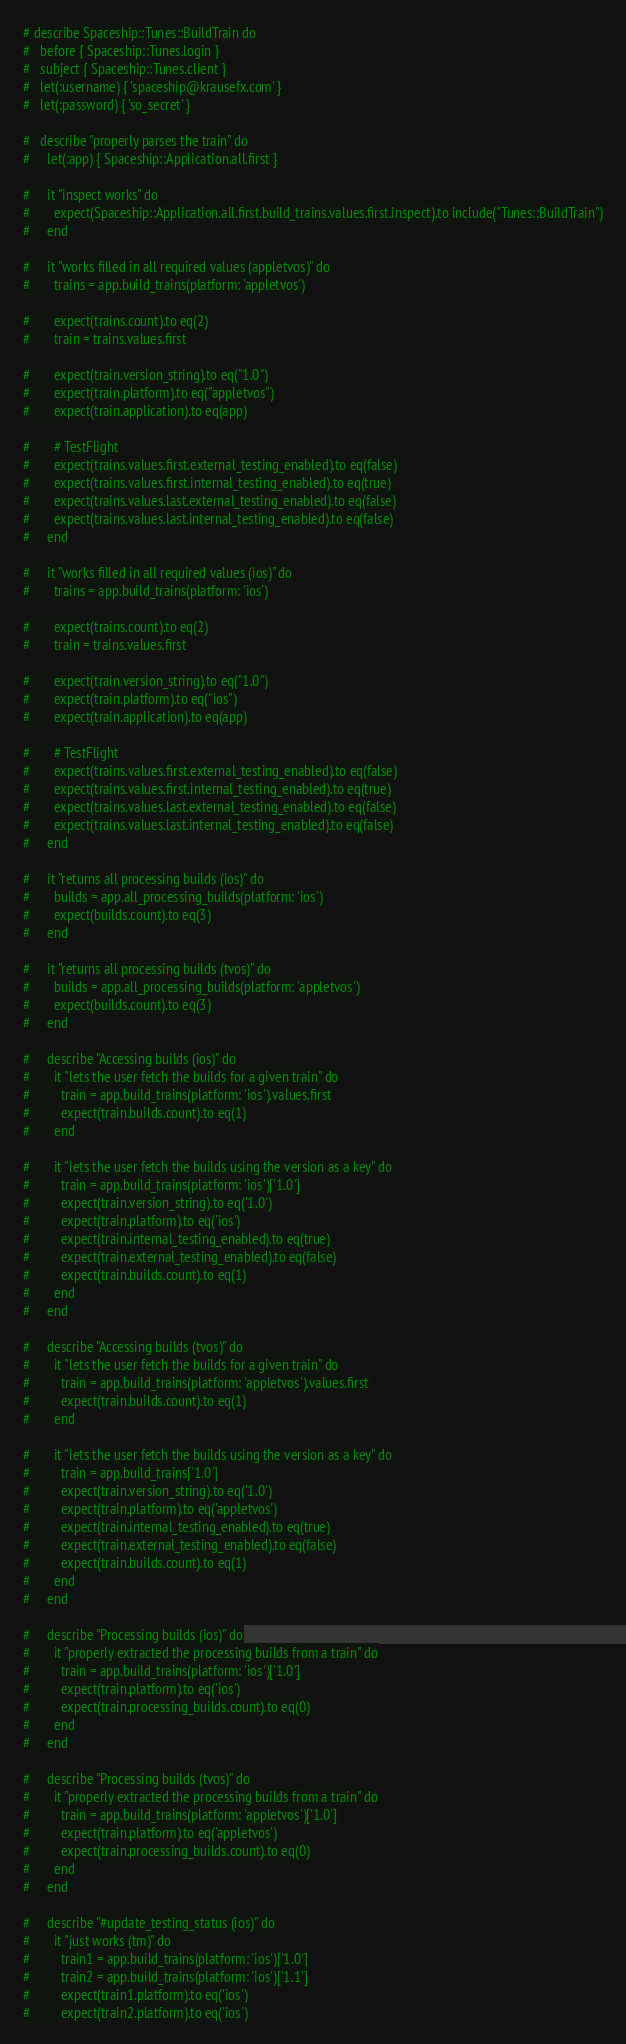<code> <loc_0><loc_0><loc_500><loc_500><_Ruby_># describe Spaceship::Tunes::BuildTrain do
#   before { Spaceship::Tunes.login }
#   subject { Spaceship::Tunes.client }
#   let(:username) { 'spaceship@krausefx.com' }
#   let(:password) { 'so_secret' }

#   describe "properly parses the train" do
#     let(:app) { Spaceship::Application.all.first }

#     it "inspect works" do
#       expect(Spaceship::Application.all.first.build_trains.values.first.inspect).to include("Tunes::BuildTrain")
#     end

#     it "works filled in all required values (appletvos)" do
#       trains = app.build_trains(platform: 'appletvos')

#       expect(trains.count).to eq(2)
#       train = trains.values.first

#       expect(train.version_string).to eq("1.0")
#       expect(train.platform).to eq("appletvos")
#       expect(train.application).to eq(app)

#       # TestFlight
#       expect(trains.values.first.external_testing_enabled).to eq(false)
#       expect(trains.values.first.internal_testing_enabled).to eq(true)
#       expect(trains.values.last.external_testing_enabled).to eq(false)
#       expect(trains.values.last.internal_testing_enabled).to eq(false)
#     end

#     it "works filled in all required values (ios)" do
#       trains = app.build_trains(platform: 'ios')

#       expect(trains.count).to eq(2)
#       train = trains.values.first

#       expect(train.version_string).to eq("1.0")
#       expect(train.platform).to eq("ios")
#       expect(train.application).to eq(app)

#       # TestFlight
#       expect(trains.values.first.external_testing_enabled).to eq(false)
#       expect(trains.values.first.internal_testing_enabled).to eq(true)
#       expect(trains.values.last.external_testing_enabled).to eq(false)
#       expect(trains.values.last.internal_testing_enabled).to eq(false)
#     end

#     it "returns all processing builds (ios)" do
#       builds = app.all_processing_builds(platform: 'ios')
#       expect(builds.count).to eq(3)
#     end

#     it "returns all processing builds (tvos)" do
#       builds = app.all_processing_builds(platform: 'appletvos')
#       expect(builds.count).to eq(3)
#     end

#     describe "Accessing builds (ios)" do
#       it "lets the user fetch the builds for a given train" do
#         train = app.build_trains(platform: 'ios').values.first
#         expect(train.builds.count).to eq(1)
#       end

#       it "lets the user fetch the builds using the version as a key" do
#         train = app.build_trains(platform: 'ios')['1.0']
#         expect(train.version_string).to eq('1.0')
#         expect(train.platform).to eq('ios')
#         expect(train.internal_testing_enabled).to eq(true)
#         expect(train.external_testing_enabled).to eq(false)
#         expect(train.builds.count).to eq(1)
#       end
#     end

#     describe "Accessing builds (tvos)" do
#       it "lets the user fetch the builds for a given train" do
#         train = app.build_trains(platform: 'appletvos').values.first
#         expect(train.builds.count).to eq(1)
#       end

#       it "lets the user fetch the builds using the version as a key" do
#         train = app.build_trains['1.0']
#         expect(train.version_string).to eq('1.0')
#         expect(train.platform).to eq('appletvos')
#         expect(train.internal_testing_enabled).to eq(true)
#         expect(train.external_testing_enabled).to eq(false)
#         expect(train.builds.count).to eq(1)
#       end
#     end

#     describe "Processing builds (ios)" do
#       it "properly extracted the processing builds from a train" do
#         train = app.build_trains(platform: 'ios')['1.0']
#         expect(train.platform).to eq('ios')
#         expect(train.processing_builds.count).to eq(0)
#       end
#     end

#     describe "Processing builds (tvos)" do
#       it "properly extracted the processing builds from a train" do
#         train = app.build_trains(platform: 'appletvos')['1.0']
#         expect(train.platform).to eq('appletvos')
#         expect(train.processing_builds.count).to eq(0)
#       end
#     end

#     describe "#update_testing_status (ios)" do
#       it "just works (tm)" do
#         train1 = app.build_trains(platform: 'ios')['1.0']
#         train2 = app.build_trains(platform: 'ios')['1.1']
#         expect(train1.platform).to eq('ios')
#         expect(train2.platform).to eq('ios')</code> 